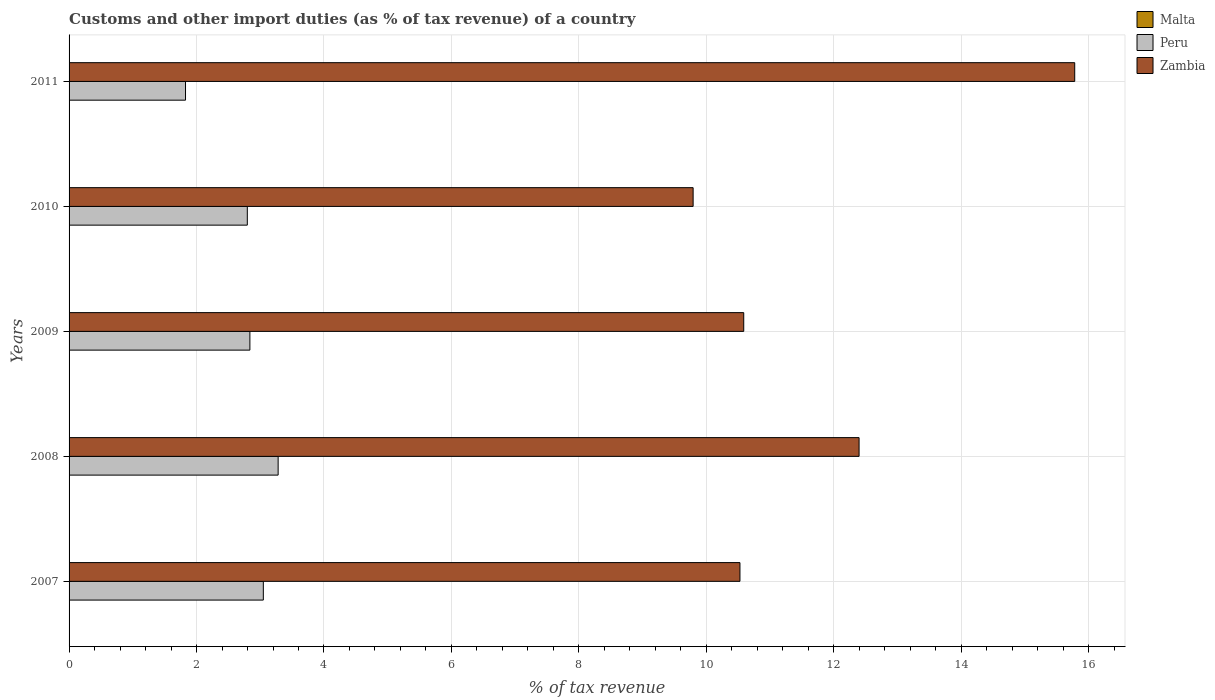How many different coloured bars are there?
Provide a succinct answer. 2. Are the number of bars on each tick of the Y-axis equal?
Give a very brief answer. Yes. How many bars are there on the 3rd tick from the top?
Provide a succinct answer. 2. How many bars are there on the 1st tick from the bottom?
Keep it short and to the point. 2. What is the label of the 1st group of bars from the top?
Your answer should be very brief. 2011. In how many cases, is the number of bars for a given year not equal to the number of legend labels?
Make the answer very short. 5. What is the percentage of tax revenue from customs in Zambia in 2011?
Provide a succinct answer. 15.78. Across all years, what is the maximum percentage of tax revenue from customs in Zambia?
Provide a short and direct response. 15.78. Across all years, what is the minimum percentage of tax revenue from customs in Peru?
Ensure brevity in your answer.  1.83. What is the total percentage of tax revenue from customs in Zambia in the graph?
Offer a very short reply. 59.08. What is the difference between the percentage of tax revenue from customs in Peru in 2007 and that in 2009?
Your answer should be very brief. 0.21. What is the difference between the percentage of tax revenue from customs in Malta in 2010 and the percentage of tax revenue from customs in Peru in 2007?
Give a very brief answer. -3.05. What is the average percentage of tax revenue from customs in Peru per year?
Your answer should be very brief. 2.76. In the year 2010, what is the difference between the percentage of tax revenue from customs in Peru and percentage of tax revenue from customs in Zambia?
Provide a short and direct response. -7. What is the ratio of the percentage of tax revenue from customs in Peru in 2007 to that in 2008?
Offer a terse response. 0.93. Is the difference between the percentage of tax revenue from customs in Peru in 2008 and 2011 greater than the difference between the percentage of tax revenue from customs in Zambia in 2008 and 2011?
Make the answer very short. Yes. What is the difference between the highest and the second highest percentage of tax revenue from customs in Peru?
Provide a succinct answer. 0.23. What is the difference between the highest and the lowest percentage of tax revenue from customs in Zambia?
Your response must be concise. 5.99. Is the sum of the percentage of tax revenue from customs in Zambia in 2009 and 2010 greater than the maximum percentage of tax revenue from customs in Peru across all years?
Your response must be concise. Yes. How many bars are there?
Provide a succinct answer. 10. How many years are there in the graph?
Provide a succinct answer. 5. What is the difference between two consecutive major ticks on the X-axis?
Offer a very short reply. 2. Does the graph contain any zero values?
Your answer should be very brief. Yes. Does the graph contain grids?
Give a very brief answer. Yes. Where does the legend appear in the graph?
Your response must be concise. Top right. How many legend labels are there?
Your answer should be compact. 3. What is the title of the graph?
Offer a very short reply. Customs and other import duties (as % of tax revenue) of a country. What is the label or title of the X-axis?
Provide a succinct answer. % of tax revenue. What is the label or title of the Y-axis?
Offer a terse response. Years. What is the % of tax revenue of Malta in 2007?
Your response must be concise. 0. What is the % of tax revenue in Peru in 2007?
Keep it short and to the point. 3.05. What is the % of tax revenue in Zambia in 2007?
Your answer should be compact. 10.53. What is the % of tax revenue in Malta in 2008?
Give a very brief answer. 0. What is the % of tax revenue of Peru in 2008?
Your answer should be very brief. 3.28. What is the % of tax revenue in Zambia in 2008?
Provide a succinct answer. 12.4. What is the % of tax revenue in Peru in 2009?
Your response must be concise. 2.84. What is the % of tax revenue of Zambia in 2009?
Your answer should be compact. 10.59. What is the % of tax revenue of Peru in 2010?
Ensure brevity in your answer.  2.8. What is the % of tax revenue of Zambia in 2010?
Provide a succinct answer. 9.79. What is the % of tax revenue in Peru in 2011?
Provide a succinct answer. 1.83. What is the % of tax revenue in Zambia in 2011?
Keep it short and to the point. 15.78. Across all years, what is the maximum % of tax revenue in Peru?
Your answer should be very brief. 3.28. Across all years, what is the maximum % of tax revenue in Zambia?
Keep it short and to the point. 15.78. Across all years, what is the minimum % of tax revenue of Peru?
Ensure brevity in your answer.  1.83. Across all years, what is the minimum % of tax revenue in Zambia?
Make the answer very short. 9.79. What is the total % of tax revenue in Peru in the graph?
Give a very brief answer. 13.79. What is the total % of tax revenue of Zambia in the graph?
Provide a short and direct response. 59.08. What is the difference between the % of tax revenue in Peru in 2007 and that in 2008?
Keep it short and to the point. -0.23. What is the difference between the % of tax revenue of Zambia in 2007 and that in 2008?
Provide a short and direct response. -1.87. What is the difference between the % of tax revenue of Peru in 2007 and that in 2009?
Provide a short and direct response. 0.21. What is the difference between the % of tax revenue in Zambia in 2007 and that in 2009?
Provide a short and direct response. -0.06. What is the difference between the % of tax revenue in Peru in 2007 and that in 2010?
Make the answer very short. 0.25. What is the difference between the % of tax revenue of Zambia in 2007 and that in 2010?
Your response must be concise. 0.73. What is the difference between the % of tax revenue in Peru in 2007 and that in 2011?
Offer a very short reply. 1.22. What is the difference between the % of tax revenue in Zambia in 2007 and that in 2011?
Offer a terse response. -5.25. What is the difference between the % of tax revenue in Peru in 2008 and that in 2009?
Keep it short and to the point. 0.44. What is the difference between the % of tax revenue in Zambia in 2008 and that in 2009?
Give a very brief answer. 1.81. What is the difference between the % of tax revenue in Peru in 2008 and that in 2010?
Give a very brief answer. 0.48. What is the difference between the % of tax revenue of Zambia in 2008 and that in 2010?
Provide a succinct answer. 2.6. What is the difference between the % of tax revenue of Peru in 2008 and that in 2011?
Provide a succinct answer. 1.45. What is the difference between the % of tax revenue of Zambia in 2008 and that in 2011?
Provide a succinct answer. -3.38. What is the difference between the % of tax revenue in Peru in 2009 and that in 2010?
Your response must be concise. 0.04. What is the difference between the % of tax revenue in Zambia in 2009 and that in 2010?
Provide a succinct answer. 0.79. What is the difference between the % of tax revenue in Peru in 2009 and that in 2011?
Your answer should be compact. 1.01. What is the difference between the % of tax revenue in Zambia in 2009 and that in 2011?
Ensure brevity in your answer.  -5.19. What is the difference between the % of tax revenue of Peru in 2010 and that in 2011?
Provide a succinct answer. 0.97. What is the difference between the % of tax revenue in Zambia in 2010 and that in 2011?
Offer a terse response. -5.99. What is the difference between the % of tax revenue in Peru in 2007 and the % of tax revenue in Zambia in 2008?
Your answer should be compact. -9.35. What is the difference between the % of tax revenue of Peru in 2007 and the % of tax revenue of Zambia in 2009?
Make the answer very short. -7.54. What is the difference between the % of tax revenue of Peru in 2007 and the % of tax revenue of Zambia in 2010?
Make the answer very short. -6.74. What is the difference between the % of tax revenue in Peru in 2007 and the % of tax revenue in Zambia in 2011?
Provide a short and direct response. -12.73. What is the difference between the % of tax revenue of Peru in 2008 and the % of tax revenue of Zambia in 2009?
Offer a very short reply. -7.31. What is the difference between the % of tax revenue in Peru in 2008 and the % of tax revenue in Zambia in 2010?
Keep it short and to the point. -6.51. What is the difference between the % of tax revenue of Peru in 2008 and the % of tax revenue of Zambia in 2011?
Give a very brief answer. -12.5. What is the difference between the % of tax revenue of Peru in 2009 and the % of tax revenue of Zambia in 2010?
Your answer should be very brief. -6.96. What is the difference between the % of tax revenue of Peru in 2009 and the % of tax revenue of Zambia in 2011?
Make the answer very short. -12.94. What is the difference between the % of tax revenue in Peru in 2010 and the % of tax revenue in Zambia in 2011?
Keep it short and to the point. -12.98. What is the average % of tax revenue of Malta per year?
Provide a succinct answer. 0. What is the average % of tax revenue of Peru per year?
Provide a short and direct response. 2.76. What is the average % of tax revenue in Zambia per year?
Keep it short and to the point. 11.82. In the year 2007, what is the difference between the % of tax revenue of Peru and % of tax revenue of Zambia?
Your answer should be compact. -7.48. In the year 2008, what is the difference between the % of tax revenue of Peru and % of tax revenue of Zambia?
Offer a very short reply. -9.12. In the year 2009, what is the difference between the % of tax revenue of Peru and % of tax revenue of Zambia?
Keep it short and to the point. -7.75. In the year 2010, what is the difference between the % of tax revenue in Peru and % of tax revenue in Zambia?
Your answer should be compact. -7. In the year 2011, what is the difference between the % of tax revenue of Peru and % of tax revenue of Zambia?
Offer a terse response. -13.95. What is the ratio of the % of tax revenue in Peru in 2007 to that in 2008?
Give a very brief answer. 0.93. What is the ratio of the % of tax revenue in Zambia in 2007 to that in 2008?
Your answer should be compact. 0.85. What is the ratio of the % of tax revenue in Peru in 2007 to that in 2009?
Give a very brief answer. 1.07. What is the ratio of the % of tax revenue of Peru in 2007 to that in 2010?
Give a very brief answer. 1.09. What is the ratio of the % of tax revenue in Zambia in 2007 to that in 2010?
Make the answer very short. 1.07. What is the ratio of the % of tax revenue of Peru in 2007 to that in 2011?
Your answer should be very brief. 1.67. What is the ratio of the % of tax revenue in Zambia in 2007 to that in 2011?
Give a very brief answer. 0.67. What is the ratio of the % of tax revenue in Peru in 2008 to that in 2009?
Your answer should be compact. 1.16. What is the ratio of the % of tax revenue of Zambia in 2008 to that in 2009?
Your answer should be compact. 1.17. What is the ratio of the % of tax revenue in Peru in 2008 to that in 2010?
Provide a succinct answer. 1.17. What is the ratio of the % of tax revenue of Zambia in 2008 to that in 2010?
Give a very brief answer. 1.27. What is the ratio of the % of tax revenue of Peru in 2008 to that in 2011?
Offer a very short reply. 1.8. What is the ratio of the % of tax revenue in Zambia in 2008 to that in 2011?
Your answer should be very brief. 0.79. What is the ratio of the % of tax revenue in Peru in 2009 to that in 2010?
Give a very brief answer. 1.01. What is the ratio of the % of tax revenue of Zambia in 2009 to that in 2010?
Make the answer very short. 1.08. What is the ratio of the % of tax revenue in Peru in 2009 to that in 2011?
Provide a short and direct response. 1.55. What is the ratio of the % of tax revenue in Zambia in 2009 to that in 2011?
Provide a succinct answer. 0.67. What is the ratio of the % of tax revenue in Peru in 2010 to that in 2011?
Your response must be concise. 1.53. What is the ratio of the % of tax revenue of Zambia in 2010 to that in 2011?
Your answer should be compact. 0.62. What is the difference between the highest and the second highest % of tax revenue of Peru?
Your answer should be very brief. 0.23. What is the difference between the highest and the second highest % of tax revenue of Zambia?
Ensure brevity in your answer.  3.38. What is the difference between the highest and the lowest % of tax revenue in Peru?
Offer a very short reply. 1.45. What is the difference between the highest and the lowest % of tax revenue in Zambia?
Offer a very short reply. 5.99. 